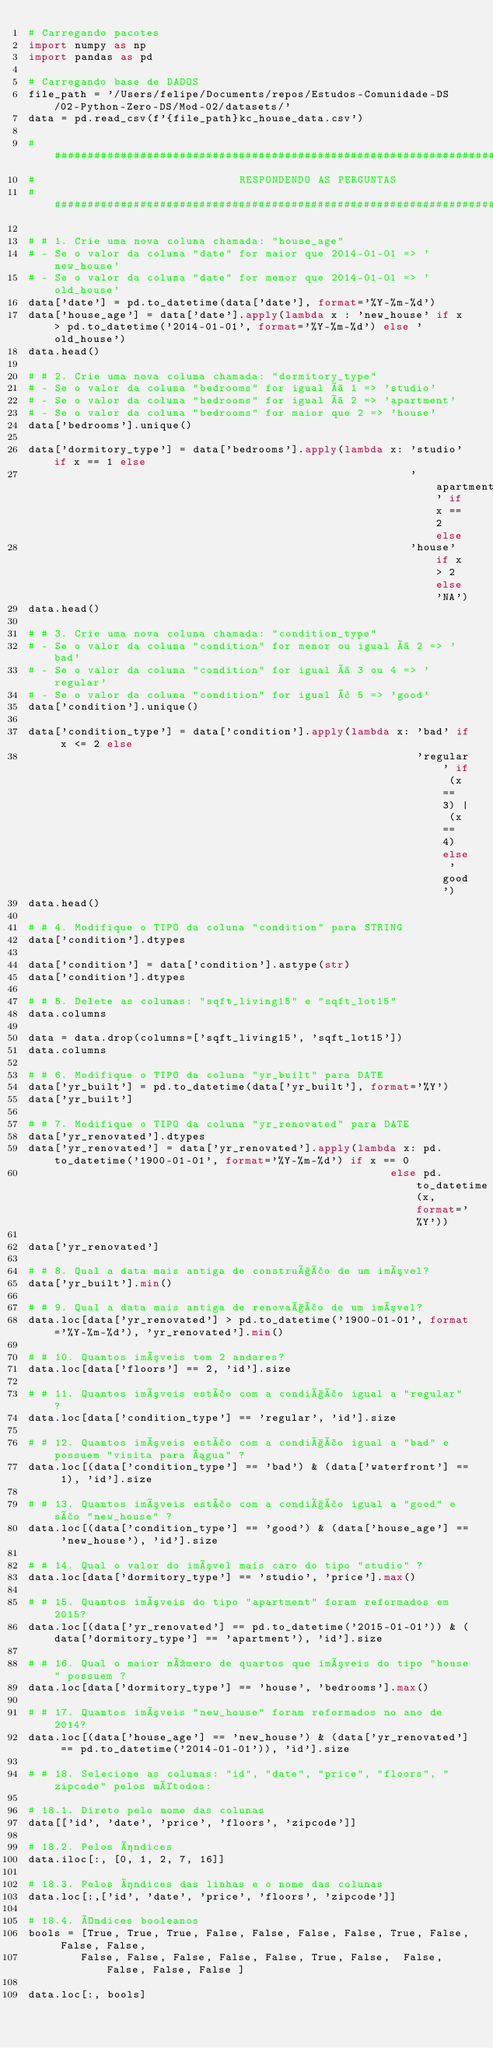Convert code to text. <code><loc_0><loc_0><loc_500><loc_500><_Python_># Carregando pacotes
import numpy as np
import pandas as pd

# Carregando base de DADOS
file_path = '/Users/felipe/Documents/repos/Estudos-Comunidade-DS/02-Python-Zero-DS/Mod-02/datasets/'
data = pd.read_csv(f'{file_path}kc_house_data.csv')

################################################################################################################################################################
#                               RESPONDENDO AS PERGUNTAS
################################################################################################################################################################

# # 1. Crie uma nova coluna chamada: "house_age"
# - Se o valor da coluna "date" for maior que 2014-01-01 => 'new_house'
# - Se o valor da coluna "date" for menor que 2014-01-01 => 'old_house'
data['date'] = pd.to_datetime(data['date'], format='%Y-%m-%d')
data['house_age'] = data['date'].apply(lambda x : 'new_house' if x > pd.to_datetime('2014-01-01', format='%Y-%m-%d') else 'old_house')
data.head()

# # 2. Crie uma nova coluna chamada: "dormitory_type"
# - Se o valor da coluna "bedrooms" for igual à 1 => 'studio'
# - Se o valor da coluna "bedrooms" for igual à 2 => 'apartment'
# - Se o valor da coluna "bedrooms" for maior que 2 => 'house'
data['bedrooms'].unique()

data['dormitory_type'] = data['bedrooms'].apply(lambda x: 'studio' if x == 1 else
                                                          'apartment' if x == 2 else
                                                          'house' if x > 2 else 'NA')
data.head()

# # 3. Crie uma nova coluna chamada: "condition_type"
# - Se o valor da coluna "condition" for menor ou igual à 2 => 'bad'
# - Se o valor da coluna "condition" for igual à 3 ou 4 => 'regular'
# - Se o valor da coluna "condition" for igual â 5 => 'good'
data['condition'].unique()

data['condition_type'] = data['condition'].apply(lambda x: 'bad' if x <= 2 else
                                                           'regular' if (x == 3) | (x == 4) else 'good')
data.head()

# # 4. Modifique o TIPO da coluna "condition" para STRING
data['condition'].dtypes

data['condition'] = data['condition'].astype(str)
data['condition'].dtypes

# # 5. Delete as colunas: "sqft_living15" e "sqft_lot15"
data.columns

data = data.drop(columns=['sqft_living15', 'sqft_lot15'])
data.columns

# # 6. Modifique o TIPO da coluna "yr_built" para DATE
data['yr_built'] = pd.to_datetime(data['yr_built'], format='%Y')
data['yr_built']

# # 7. Modifique o TIPO da coluna "yr_renovated" para DATE
data['yr_renovated'].dtypes
data['yr_renovated'] = data['yr_renovated'].apply(lambda x: pd.to_datetime('1900-01-01', format='%Y-%m-%d') if x == 0
                                                       else pd.to_datetime(x, format='%Y'))

data['yr_renovated']

# # 8. Qual a data mais antiga de construção de um imóvel?
data['yr_built'].min()

# # 9. Qual a data mais antiga de renovação de um imóvel?
data.loc[data['yr_renovated'] > pd.to_datetime('1900-01-01', format='%Y-%m-%d'), 'yr_renovated'].min()

# # 10. Quantos imóveis tem 2 andares?
data.loc[data['floors'] == 2, 'id'].size

# # 11. Quantos imóveis estão com a condição igual a "regular" ?
data.loc[data['condition_type'] == 'regular', 'id'].size

# # 12. Quantos imóveis estão com a condição igual a "bad" e possuem "visita para água" ?
data.loc[(data['condition_type'] == 'bad') & (data['waterfront'] == 1), 'id'].size

# # 13. Quantos imóveis estão com a condição igual a "good" e são "new_house" ?
data.loc[(data['condition_type'] == 'good') & (data['house_age'] == 'new_house'), 'id'].size

# # 14. Qual o valor do imóvel mais caro do tipo "studio" ?
data.loc[data['dormitory_type'] == 'studio', 'price'].max()

# # 15. Quantos imóveis do tipo "apartment" foram reformados em 2015?
data.loc[(data['yr_renovated'] == pd.to_datetime('2015-01-01')) & (data['dormitory_type'] == 'apartment'), 'id'].size

# # 16. Qual o maior número de quartos que imóveis do tipo "house" possuem ?
data.loc[data['dormitory_type'] == 'house', 'bedrooms'].max()

# # 17. Quantos imóveis "new_house" foram reformados no ano de 2014?
data.loc[(data['house_age'] == 'new_house') & (data['yr_renovated'] == pd.to_datetime('2014-01-01')), 'id'].size

# # 18. Selecione as colunas: "id", "date", "price", "floors", "zipcode" pelos métodos:

# 18.1. Direto pelo nome das colunas
data[['id', 'date', 'price', 'floors', 'zipcode']]

# 18.2. Pelos índices
data.iloc[:, [0, 1, 2, 7, 16]]

# 18.3. Pelos índices das linhas e o nome das colunas
data.loc[:,['id', 'date', 'price', 'floors', 'zipcode']]

# 18.4. Índices booleanos
bools = [True, True, True, False, False, False, False, True, False, False, False,
        False, False, False, False, False, True, False,  False, False, False, False ]

data.loc[:, bools]
</code> 